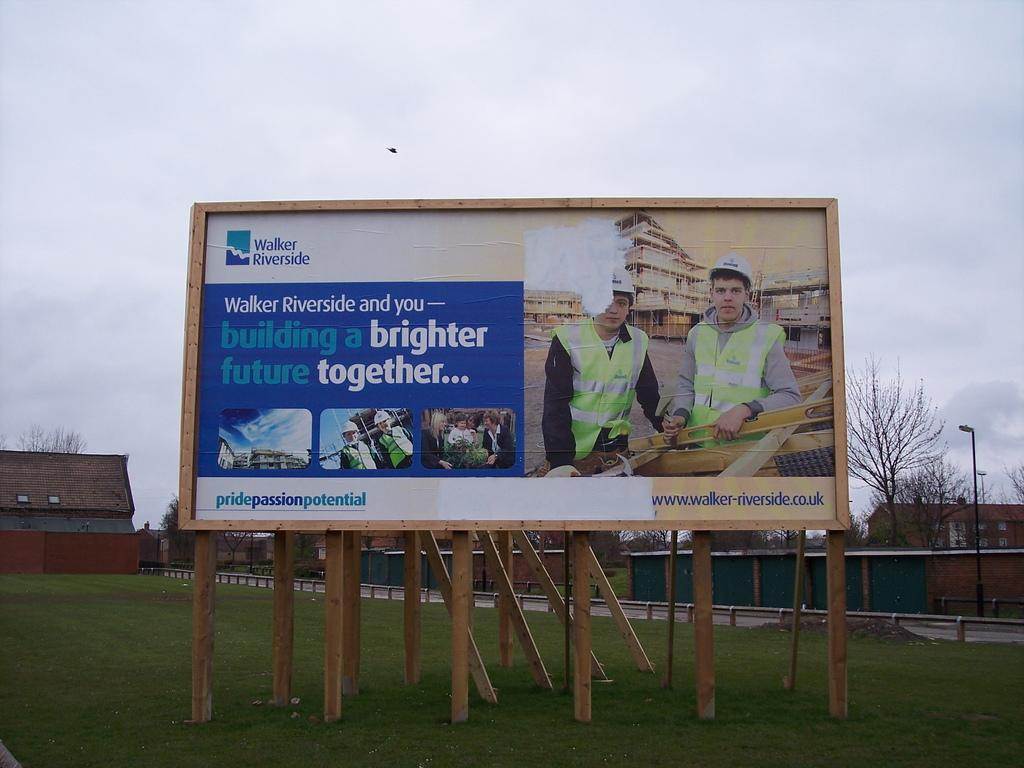<image>
Present a compact description of the photo's key features. A billboard from Walker Riverside shows two construction workers. 